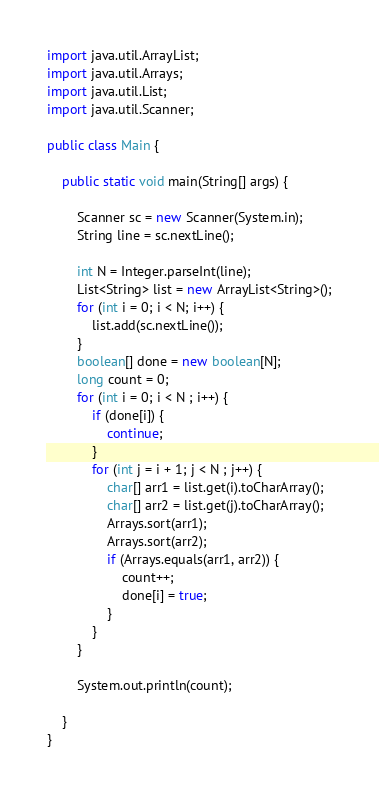Convert code to text. <code><loc_0><loc_0><loc_500><loc_500><_Java_>import java.util.ArrayList;
import java.util.Arrays;
import java.util.List;
import java.util.Scanner;

public class Main {

    public static void main(String[] args) {

        Scanner sc = new Scanner(System.in);
        String line = sc.nextLine();
        
        int N = Integer.parseInt(line);
        List<String> list = new ArrayList<String>();
        for (int i = 0; i < N; i++) {
            list.add(sc.nextLine());
        }
        boolean[] done = new boolean[N];
        long count = 0;
        for (int i = 0; i < N ; i++) {
            if (done[i]) {
                continue;
            }
            for (int j = i + 1; j < N ; j++) {
                char[] arr1 = list.get(i).toCharArray();
                char[] arr2 = list.get(j).toCharArray();
                Arrays.sort(arr1);
                Arrays.sort(arr2);
                if (Arrays.equals(arr1, arr2)) {
                    count++;
                    done[i] = true;
                }
            }
        }
        
        System.out.println(count);

    }
}</code> 